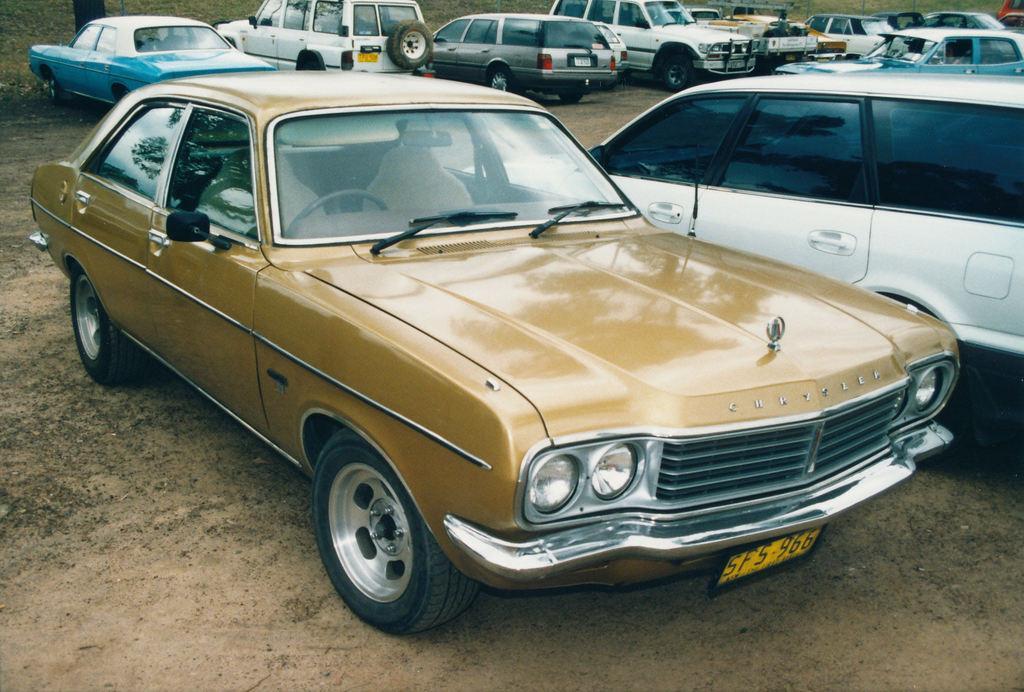Can you describe this image briefly? In this picture we can see some vehicles, it looks like a tree at the left top of the picture. 